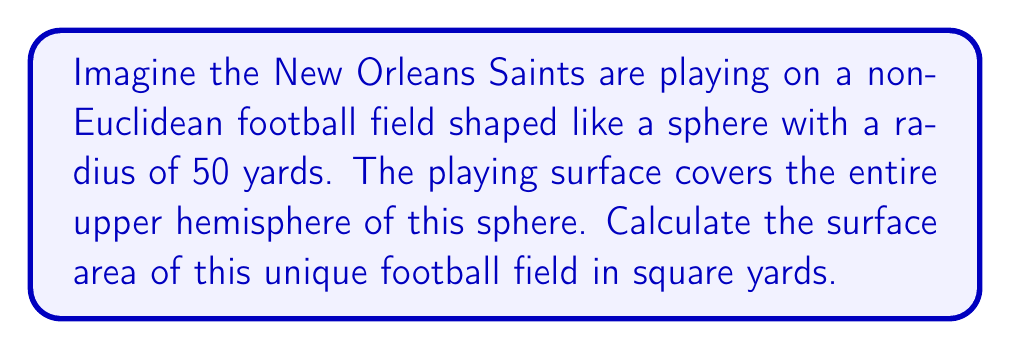Teach me how to tackle this problem. To solve this problem, we need to use the formula for the surface area of a hemisphere. Let's break it down step-by-step:

1) The formula for the surface area of a sphere is:
   $$A_{sphere} = 4\pi r^2$$

2) Since we're only dealing with the upper hemisphere (half of the sphere), we need to divide this by 2 and add the area of the circular base:
   $$A_{hemisphere} = \frac{1}{2}(4\pi r^2) + \pi r^2 = 2\pi r^2 + \pi r^2 = 3\pi r^2$$

3) We're given that the radius is 50 yards. Let's substitute this into our formula:
   $$A = 3\pi (50)^2$$

4) Simplify:
   $$A = 3\pi (2500) = 7500\pi$$

5) To get the final answer in square yards, we can leave it as $7500\pi$ or calculate the approximate value:
   $$A \approx 23,561.94$$

This unique spherical field would present interesting challenges for the Saints, as players would need to account for the curvature of the playing surface, especially for long passes and kicks!
Answer: The surface area of the non-Euclidean football field is $7500\pi$ square yards, or approximately 23,561.94 square yards. 